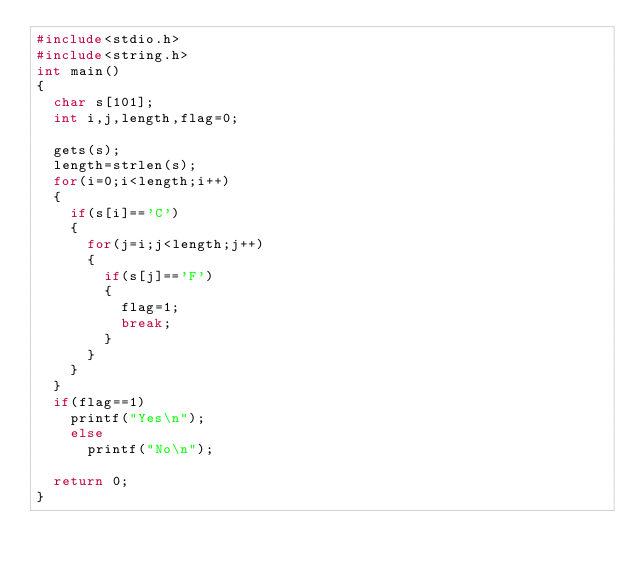<code> <loc_0><loc_0><loc_500><loc_500><_C_>#include<stdio.h>
#include<string.h>
int main()
{
	char s[101];
	int i,j,length,flag=0;
	
	gets(s);
	length=strlen(s);
	for(i=0;i<length;i++)
	{
		if(s[i]=='C')
		{
			for(j=i;j<length;j++)
			{
				if(s[j]=='F')
				{
					flag=1;
					break;
				}
			}
		}
	}
	if(flag==1)
	  printf("Yes\n");
    else
      printf("No\n");
	
	return 0;
} 
</code> 